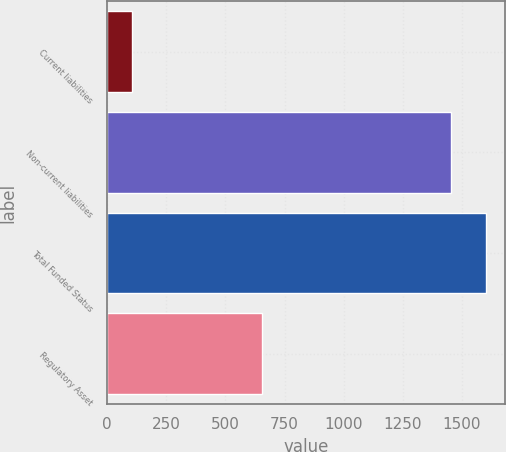Convert chart. <chart><loc_0><loc_0><loc_500><loc_500><bar_chart><fcel>Current liabilities<fcel>Non-current liabilities<fcel>Total Funded Status<fcel>Regulatory Asset<nl><fcel>107<fcel>1454<fcel>1599.4<fcel>654<nl></chart> 